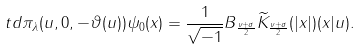<formula> <loc_0><loc_0><loc_500><loc_500>\ t d \pi _ { \lambda } ( u , 0 , - \vartheta ( u ) ) \psi _ { 0 } ( x ) & = \frac { 1 } { \sqrt { - 1 } } B _ { \frac { \nu + \sigma } { 2 } } \widetilde { K } _ { \frac { \nu + \sigma } { 2 } } ( | x | ) ( x | u ) .</formula> 